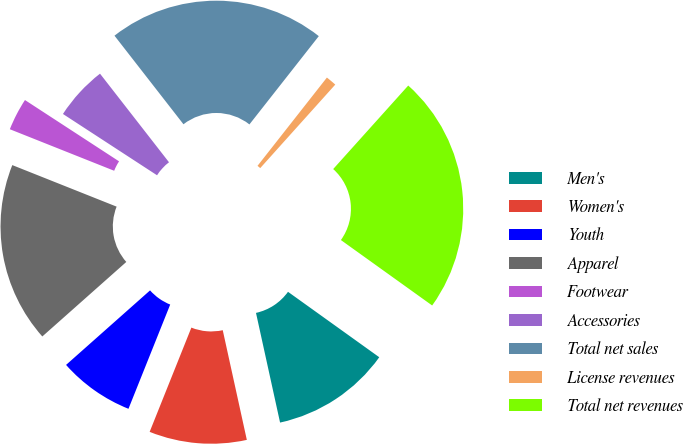<chart> <loc_0><loc_0><loc_500><loc_500><pie_chart><fcel>Men's<fcel>Women's<fcel>Youth<fcel>Apparel<fcel>Footwear<fcel>Accessories<fcel>Total net sales<fcel>License revenues<fcel>Total net revenues<nl><fcel>11.66%<fcel>9.5%<fcel>7.39%<fcel>17.58%<fcel>3.16%<fcel>5.28%<fcel>21.13%<fcel>1.05%<fcel>23.25%<nl></chart> 